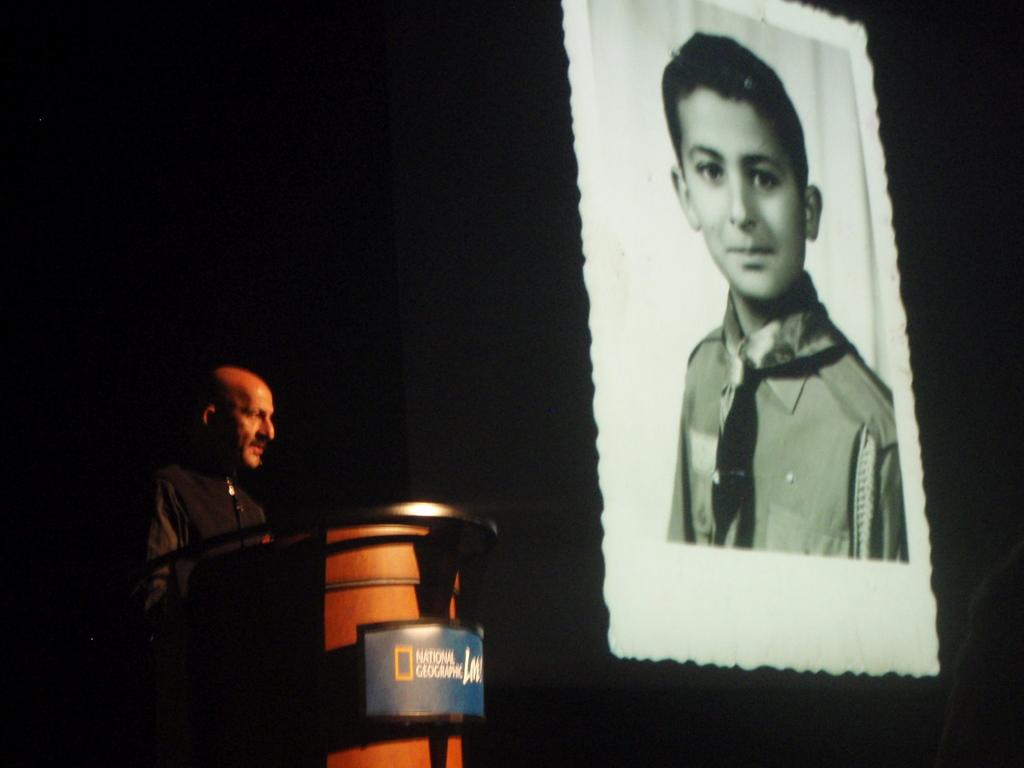What is the person in the image doing? The person is standing in front of the podium. How would you describe the background of the image? The background of the image is dark. What can be seen in the middle of the image? There is a boy's image in the middle of the image. What type of linen is draped over the podium in the image? There is no linen present in the image, and the podium is not draped with any fabric. 